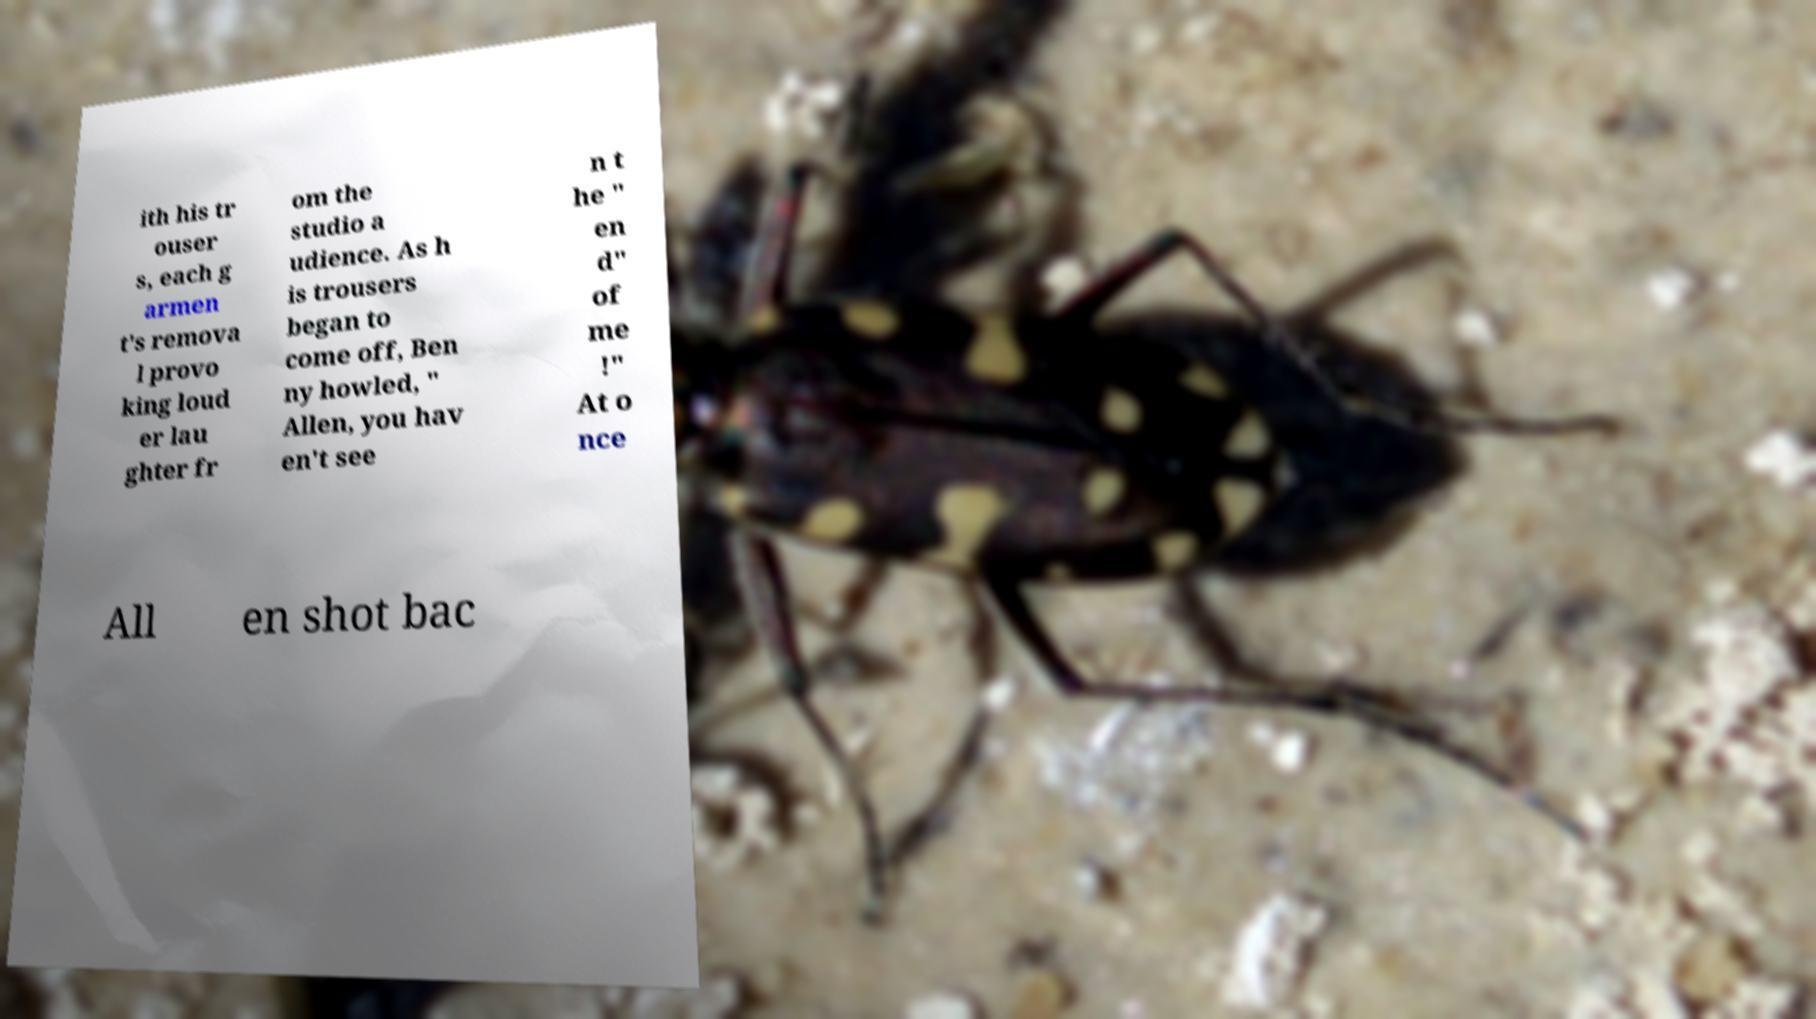For documentation purposes, I need the text within this image transcribed. Could you provide that? ith his tr ouser s, each g armen t's remova l provo king loud er lau ghter fr om the studio a udience. As h is trousers began to come off, Ben ny howled, " Allen, you hav en't see n t he " en d" of me !" At o nce All en shot bac 